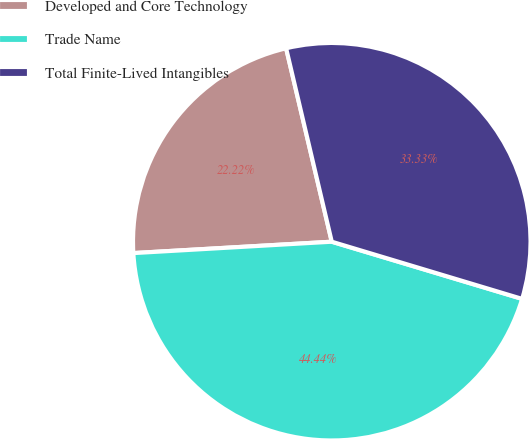Convert chart to OTSL. <chart><loc_0><loc_0><loc_500><loc_500><pie_chart><fcel>Developed and Core Technology<fcel>Trade Name<fcel>Total Finite-Lived Intangibles<nl><fcel>22.22%<fcel>44.44%<fcel>33.33%<nl></chart> 